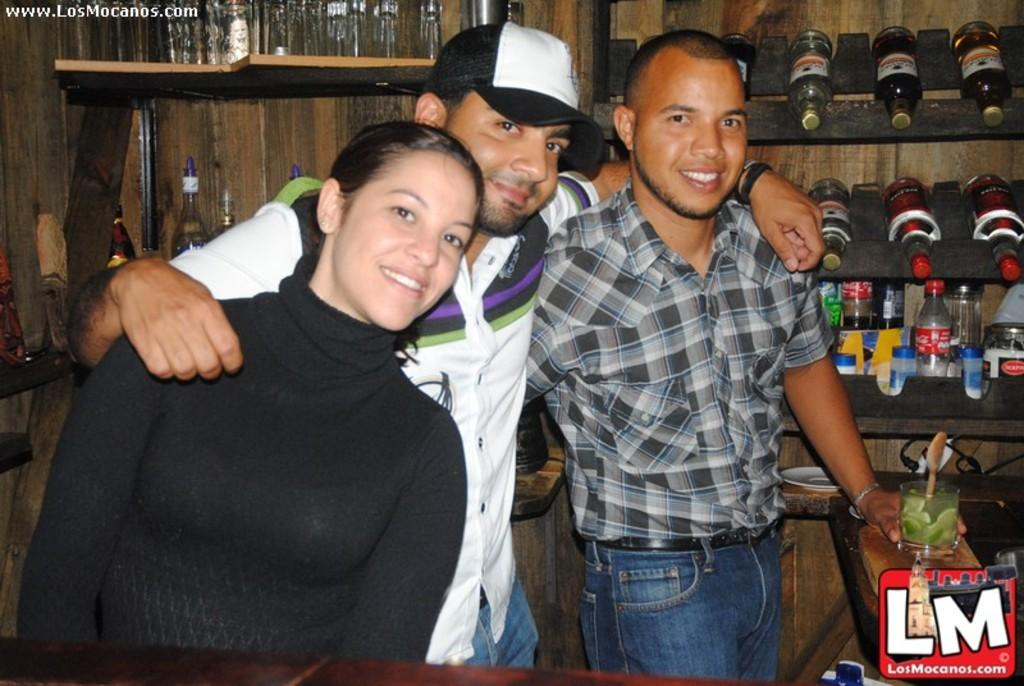What is happening in the foreground of the image? There are people standing in the foreground of the image. What can be seen in the background of the image? There are bottles in racks in the background of the image. Where is the logo located in the image? The logo is at the bottom of the image. Can you tell me how many monkeys are holding the bottles in the image? There are no monkeys present in the image; it features people standing in the foreground and bottles in racks in the background. What type of belief is represented by the logo at the bottom of the image? The image does not provide any information about the beliefs associated with the logo; it only shows the logo's location. 